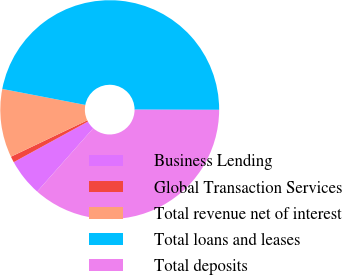<chart> <loc_0><loc_0><loc_500><loc_500><pie_chart><fcel>Business Lending<fcel>Global Transaction Services<fcel>Total revenue net of interest<fcel>Total loans and leases<fcel>Total deposits<nl><fcel>5.5%<fcel>0.89%<fcel>10.11%<fcel>47.0%<fcel>36.5%<nl></chart> 